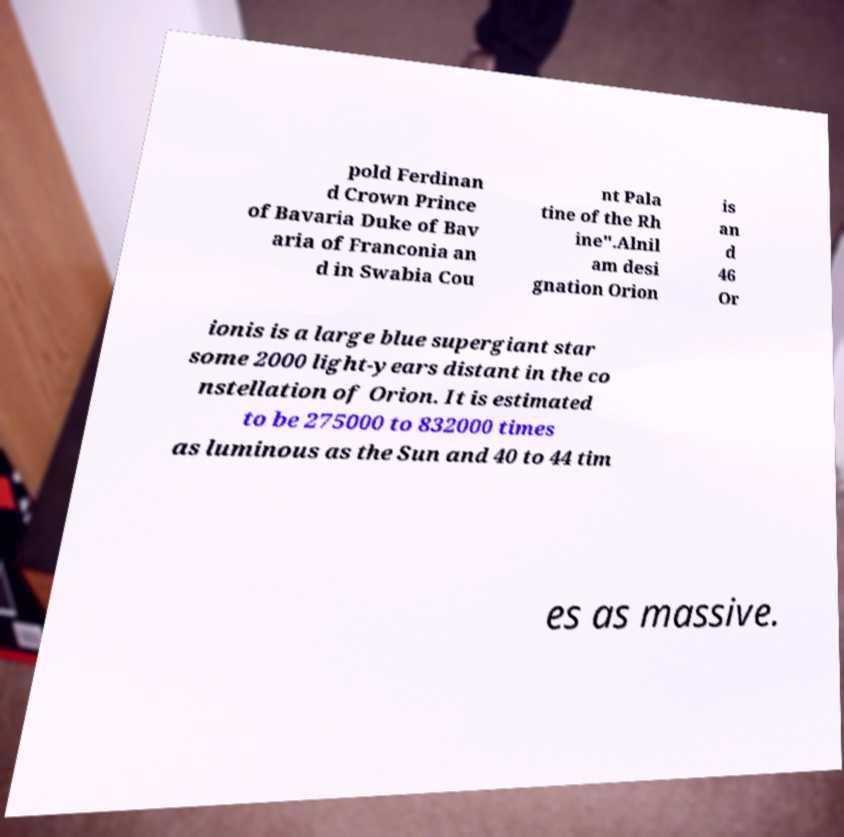For documentation purposes, I need the text within this image transcribed. Could you provide that? pold Ferdinan d Crown Prince of Bavaria Duke of Bav aria of Franconia an d in Swabia Cou nt Pala tine of the Rh ine".Alnil am desi gnation Orion is an d 46 Or ionis is a large blue supergiant star some 2000 light-years distant in the co nstellation of Orion. It is estimated to be 275000 to 832000 times as luminous as the Sun and 40 to 44 tim es as massive. 